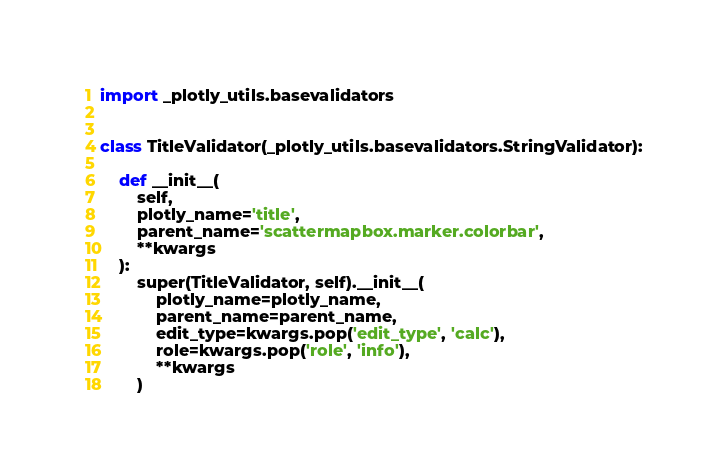<code> <loc_0><loc_0><loc_500><loc_500><_Python_>import _plotly_utils.basevalidators


class TitleValidator(_plotly_utils.basevalidators.StringValidator):

    def __init__(
        self,
        plotly_name='title',
        parent_name='scattermapbox.marker.colorbar',
        **kwargs
    ):
        super(TitleValidator, self).__init__(
            plotly_name=plotly_name,
            parent_name=parent_name,
            edit_type=kwargs.pop('edit_type', 'calc'),
            role=kwargs.pop('role', 'info'),
            **kwargs
        )
</code> 